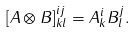<formula> <loc_0><loc_0><loc_500><loc_500>[ A \otimes B ] ^ { i j } _ { k l } = A ^ { i } _ { k } B ^ { j } _ { l } .</formula> 